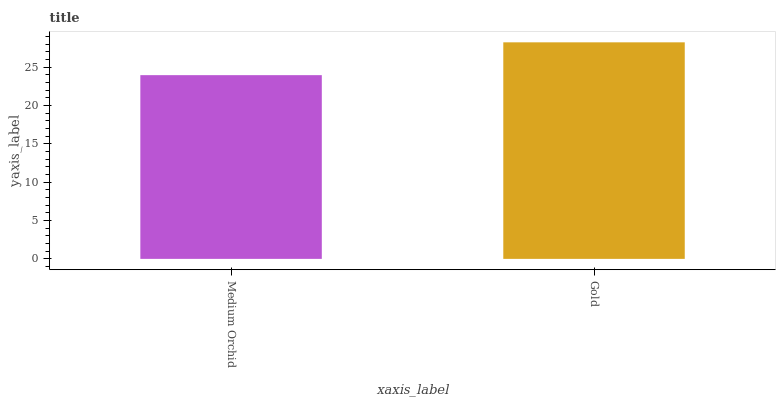Is Medium Orchid the minimum?
Answer yes or no. Yes. Is Gold the maximum?
Answer yes or no. Yes. Is Gold the minimum?
Answer yes or no. No. Is Gold greater than Medium Orchid?
Answer yes or no. Yes. Is Medium Orchid less than Gold?
Answer yes or no. Yes. Is Medium Orchid greater than Gold?
Answer yes or no. No. Is Gold less than Medium Orchid?
Answer yes or no. No. Is Gold the high median?
Answer yes or no. Yes. Is Medium Orchid the low median?
Answer yes or no. Yes. Is Medium Orchid the high median?
Answer yes or no. No. Is Gold the low median?
Answer yes or no. No. 